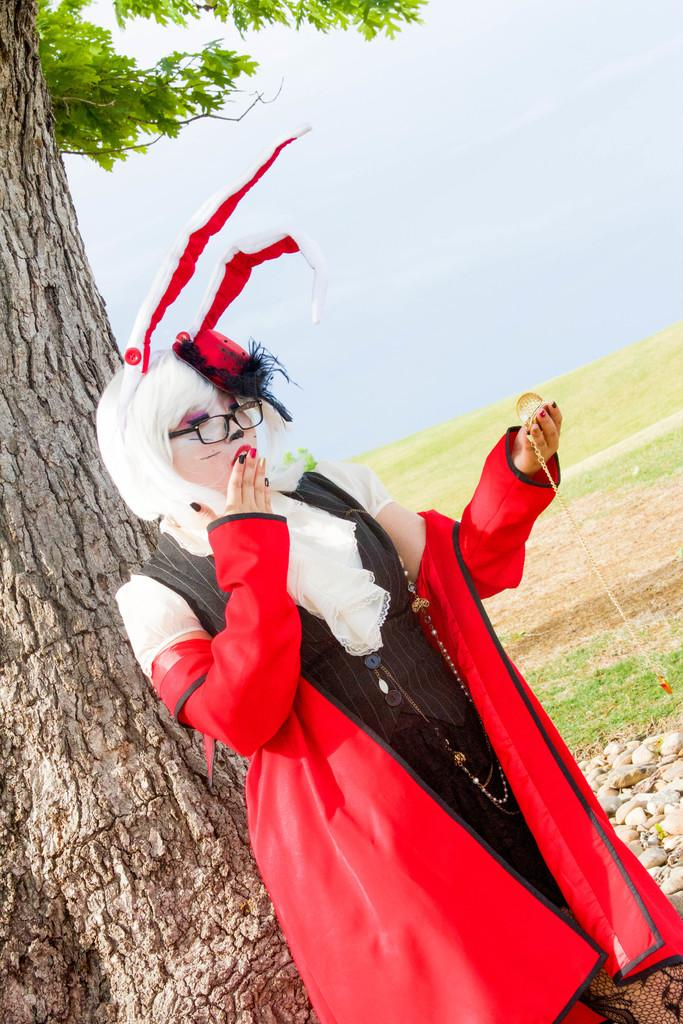What is the main subject of the image? There is a person standing in the center of the image. What is the person holding in the image? The person is holding an object. What can be seen in the background of the image? There is sky, at least one tree, and grass visible in the background of the image. How many teeth can be seen falling out of the person's mouth in the image? There is no indication in the image that the person is losing any teeth, and therefore no teeth can be seen falling out. 